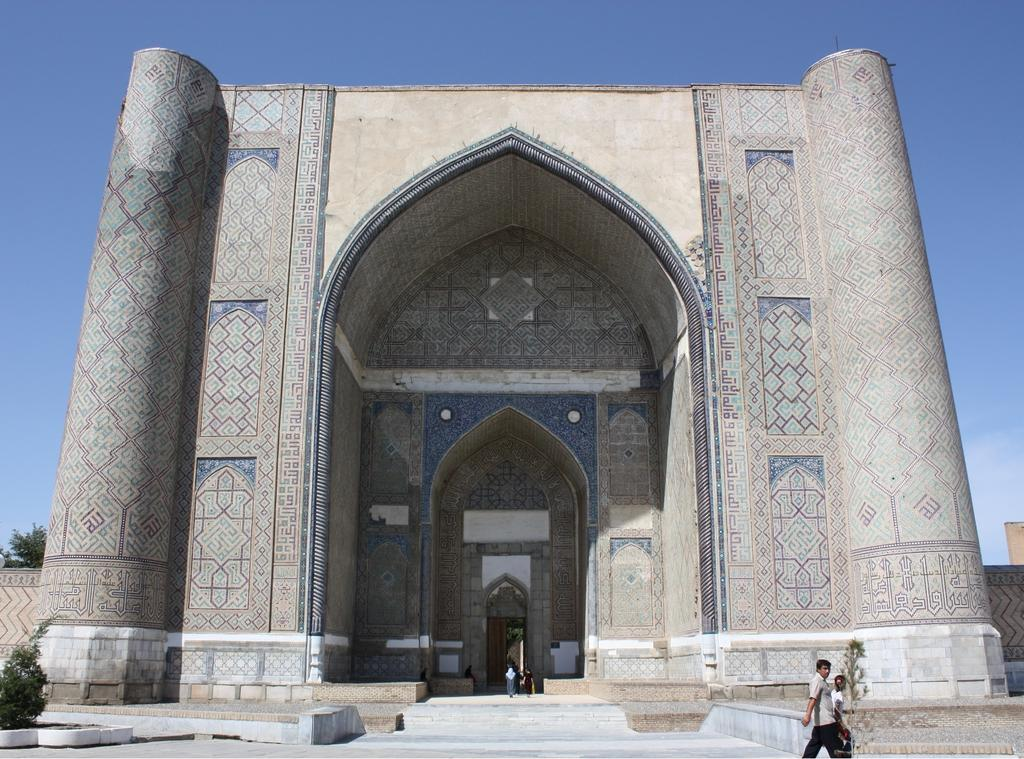What is the main structure in the image? There is a monument in the image. What are the two persons in the image doing? The two persons are walking in front of the monument. What can be seen at the top of the image? The sky is visible at the top of the image. What type of vegetation is on the left side of the image? There are plants on the left side of the image. How many snails can be seen crawling on the monument in the image? There are no snails visible on the monument in the image. What type of rock is the monument made of in the image? The provided facts do not mention the material of the monument, so we cannot determine the type of rock it is made of. 